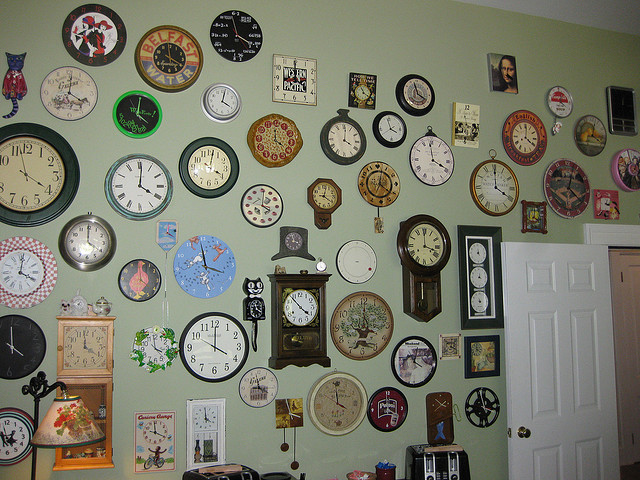Can you describe the most unique clock on the wall? One of the most unique clocks is the cat clock with moving eyes and tail, positioned towards the left side above the mantel. It combines functionality and quirky style. 